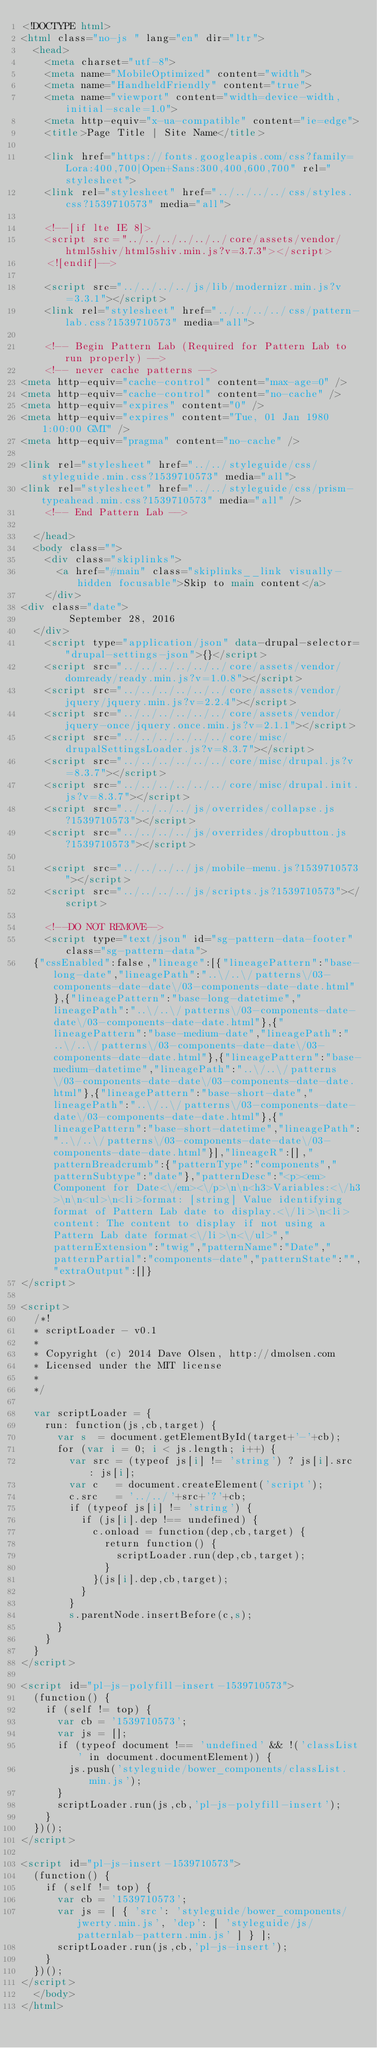Convert code to text. <code><loc_0><loc_0><loc_500><loc_500><_HTML_><!DOCTYPE html>
<html class="no-js " lang="en" dir="ltr">
  <head>
    <meta charset="utf-8">
    <meta name="MobileOptimized" content="width">
    <meta name="HandheldFriendly" content="true">
    <meta name="viewport" content="width=device-width, initial-scale=1.0">
    <meta http-equiv="x-ua-compatible" content="ie=edge">
    <title>Page Title | Site Name</title>

    <link href="https://fonts.googleapis.com/css?family=Lora:400,700|Open+Sans:300,400,600,700" rel="stylesheet">
    <link rel="stylesheet" href="../../../../css/styles.css?1539710573" media="all">
    
    <!--[if lte IE 8]>
    <script src="../../../../../../core/assets/vendor/html5shiv/html5shiv.min.js?v=3.7.3"></script>
    <![endif]-->

    <script src="../../../../js/lib/modernizr.min.js?v=3.3.1"></script>
    <link rel="stylesheet" href="../../../../css/pattern-lab.css?1539710573" media="all">

    <!-- Begin Pattern Lab (Required for Pattern Lab to run properly) -->
    <!-- never cache patterns -->
<meta http-equiv="cache-control" content="max-age=0" />
<meta http-equiv="cache-control" content="no-cache" />
<meta http-equiv="expires" content="0" />
<meta http-equiv="expires" content="Tue, 01 Jan 1980 1:00:00 GMT" />
<meta http-equiv="pragma" content="no-cache" />

<link rel="stylesheet" href="../../styleguide/css/styleguide.min.css?1539710573" media="all">
<link rel="stylesheet" href="../../styleguide/css/prism-typeahead.min.css?1539710573" media="all" />
    <!-- End Pattern Lab -->

  </head>
  <body class="">
    <div class="skiplinks">
      <a href="#main" class="skiplinks__link visually-hidden focusable">Skip to main content</a>
    </div>
<div class="date">
        September 28, 2016
  </div>
    <script type="application/json" data-drupal-selector="drupal-settings-json">{}</script>
    <script src="../../../../../../core/assets/vendor/domready/ready.min.js?v=1.0.8"></script>
    <script src="../../../../../../core/assets/vendor/jquery/jquery.min.js?v=2.2.4"></script>
    <script src="../../../../../../core/assets/vendor/jquery-once/jquery.once.min.js?v=2.1.1"></script>
    <script src="../../../../../../core/misc/drupalSettingsLoader.js?v=8.3.7"></script>
    <script src="../../../../../../core/misc/drupal.js?v=8.3.7"></script>
    <script src="../../../../../../core/misc/drupal.init.js?v=8.3.7"></script>
    <script src="../../../../js/overrides/collapse.js?1539710573"></script>
    <script src="../../../../js/overrides/dropbutton.js?1539710573"></script>

    <script src="../../../../js/mobile-menu.js?1539710573"></script>
    <script src="../../../../js/scripts.js?1539710573"></script>

    <!--DO NOT REMOVE-->
    <script type="text/json" id="sg-pattern-data-footer" class="sg-pattern-data">
  {"cssEnabled":false,"lineage":[{"lineagePattern":"base-long-date","lineagePath":"..\/..\/patterns\/03-components-date-date\/03-components-date-date.html"},{"lineagePattern":"base-long-datetime","lineagePath":"..\/..\/patterns\/03-components-date-date\/03-components-date-date.html"},{"lineagePattern":"base-medium-date","lineagePath":"..\/..\/patterns\/03-components-date-date\/03-components-date-date.html"},{"lineagePattern":"base-medium-datetime","lineagePath":"..\/..\/patterns\/03-components-date-date\/03-components-date-date.html"},{"lineagePattern":"base-short-date","lineagePath":"..\/..\/patterns\/03-components-date-date\/03-components-date-date.html"},{"lineagePattern":"base-short-datetime","lineagePath":"..\/..\/patterns\/03-components-date-date\/03-components-date-date.html"}],"lineageR":[],"patternBreadcrumb":{"patternType":"components","patternSubtype":"date"},"patternDesc":"<p><em>Component for Date<\/em><\/p>\n\n<h3>Variables:<\/h3>\n\n<ul>\n<li>format: [string] Value identifying format of Pattern Lab date to display.<\/li>\n<li>content: The content to display if not using a Pattern Lab date format<\/li>\n<\/ul>","patternExtension":"twig","patternName":"Date","patternPartial":"components-date","patternState":"","extraOutput":[]}
</script>

<script>
  /*!
  * scriptLoader - v0.1
  *
  * Copyright (c) 2014 Dave Olsen, http://dmolsen.com
  * Licensed under the MIT license
  *
  */
  
  var scriptLoader = {
    run: function(js,cb,target) {
      var s  = document.getElementById(target+'-'+cb);
      for (var i = 0; i < js.length; i++) {
        var src = (typeof js[i] != 'string') ? js[i].src : js[i];
        var c   = document.createElement('script');
        c.src   = '../../'+src+'?'+cb;
        if (typeof js[i] != 'string') {
          if (js[i].dep !== undefined) {
            c.onload = function(dep,cb,target) {
              return function() {
                scriptLoader.run(dep,cb,target);
              }
            }(js[i].dep,cb,target);
          }
        }
        s.parentNode.insertBefore(c,s);
      }
    }
  }
</script>

<script id="pl-js-polyfill-insert-1539710573">
  (function() {
    if (self != top) {
      var cb = '1539710573';
      var js = [];
      if (typeof document !== 'undefined' && !('classList' in document.documentElement)) {
        js.push('styleguide/bower_components/classList.min.js');
      }
      scriptLoader.run(js,cb,'pl-js-polyfill-insert');
    }
  })();
</script>

<script id="pl-js-insert-1539710573">
  (function() {
    if (self != top) {
      var cb = '1539710573';
      var js = [ { 'src': 'styleguide/bower_components/jwerty.min.js', 'dep': [ 'styleguide/js/patternlab-pattern.min.js' ] } ];
      scriptLoader.run(js,cb,'pl-js-insert');
    }
  })();
</script>
  </body>
</html>
</code> 